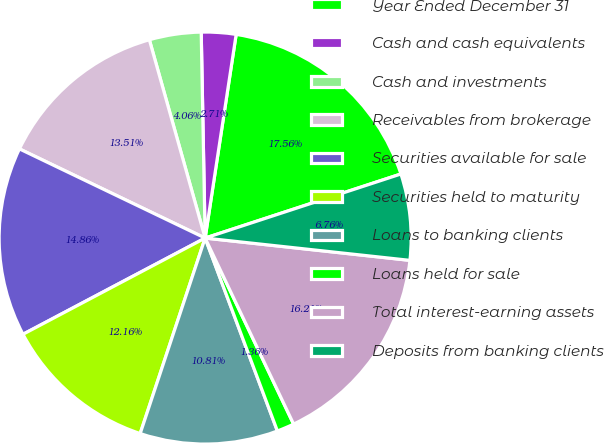Convert chart to OTSL. <chart><loc_0><loc_0><loc_500><loc_500><pie_chart><fcel>Year Ended December 31<fcel>Cash and cash equivalents<fcel>Cash and investments<fcel>Receivables from brokerage<fcel>Securities available for sale<fcel>Securities held to maturity<fcel>Loans to banking clients<fcel>Loans held for sale<fcel>Total interest-earning assets<fcel>Deposits from banking clients<nl><fcel>17.56%<fcel>2.71%<fcel>4.06%<fcel>13.51%<fcel>14.86%<fcel>12.16%<fcel>10.81%<fcel>1.36%<fcel>16.21%<fcel>6.76%<nl></chart> 